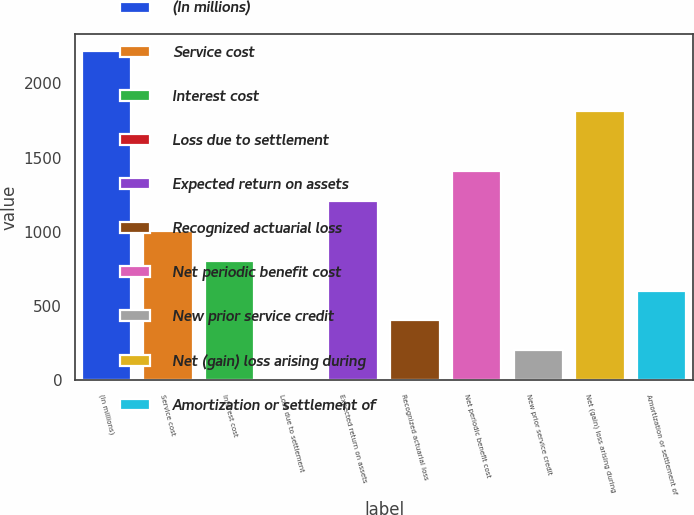<chart> <loc_0><loc_0><loc_500><loc_500><bar_chart><fcel>(In millions)<fcel>Service cost<fcel>Interest cost<fcel>Loss due to settlement<fcel>Expected return on assets<fcel>Recognized actuarial loss<fcel>Net periodic benefit cost<fcel>New prior service credit<fcel>Net (gain) loss arising during<fcel>Amortization or settlement of<nl><fcel>2217.5<fcel>1008.5<fcel>807<fcel>1<fcel>1210<fcel>404<fcel>1411.5<fcel>202.5<fcel>1814.5<fcel>605.5<nl></chart> 